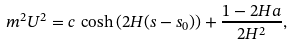<formula> <loc_0><loc_0><loc_500><loc_500>m ^ { 2 } U ^ { 2 } = c \, \cosh \left ( 2 H ( s - s _ { 0 } ) \right ) + \frac { 1 - 2 H a } { 2 H ^ { 2 } } ,</formula> 